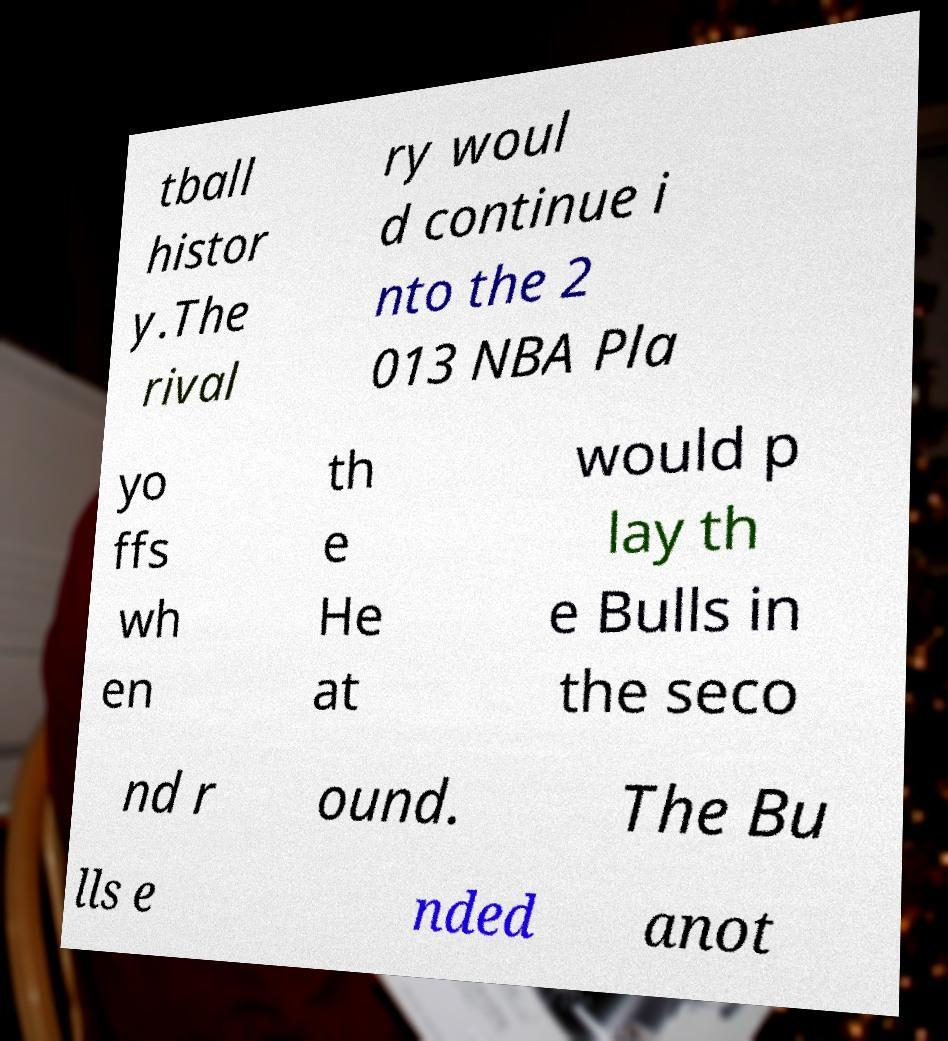Please identify and transcribe the text found in this image. tball histor y.The rival ry woul d continue i nto the 2 013 NBA Pla yo ffs wh en th e He at would p lay th e Bulls in the seco nd r ound. The Bu lls e nded anot 